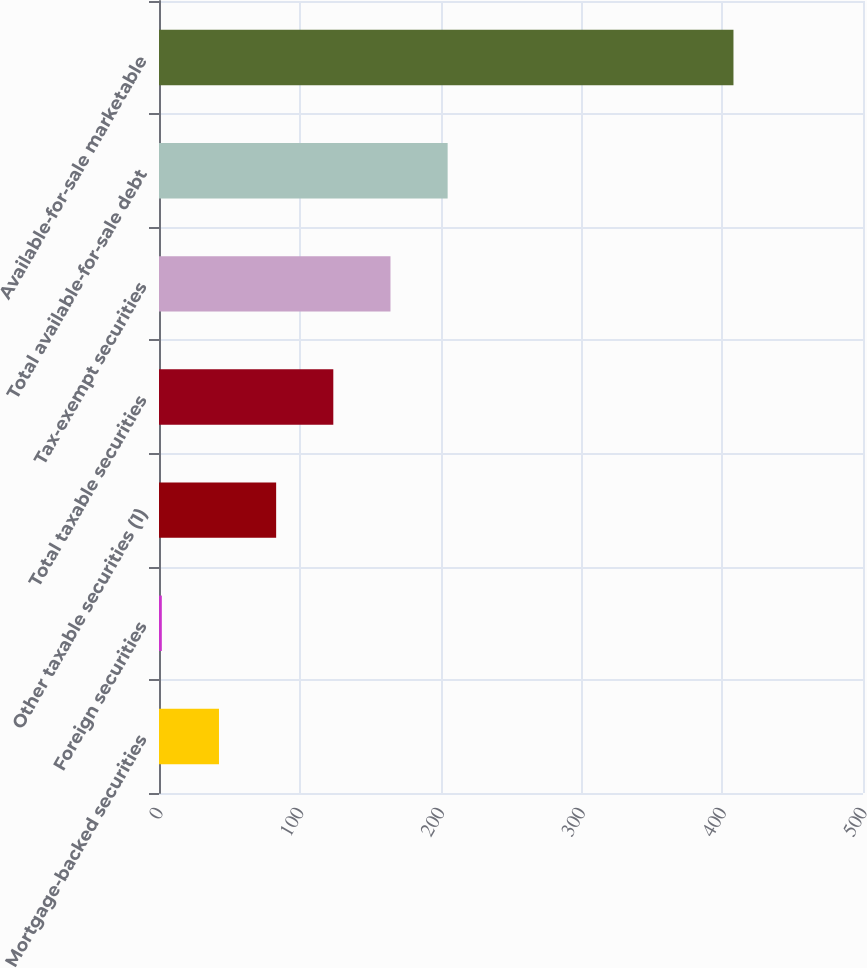<chart> <loc_0><loc_0><loc_500><loc_500><bar_chart><fcel>Mortgage-backed securities<fcel>Foreign securities<fcel>Other taxable securities (1)<fcel>Total taxable securities<fcel>Tax-exempt securities<fcel>Total available-for-sale debt<fcel>Available-for-sale marketable<nl><fcel>42.6<fcel>2<fcel>83.2<fcel>123.8<fcel>164.4<fcel>205<fcel>408<nl></chart> 